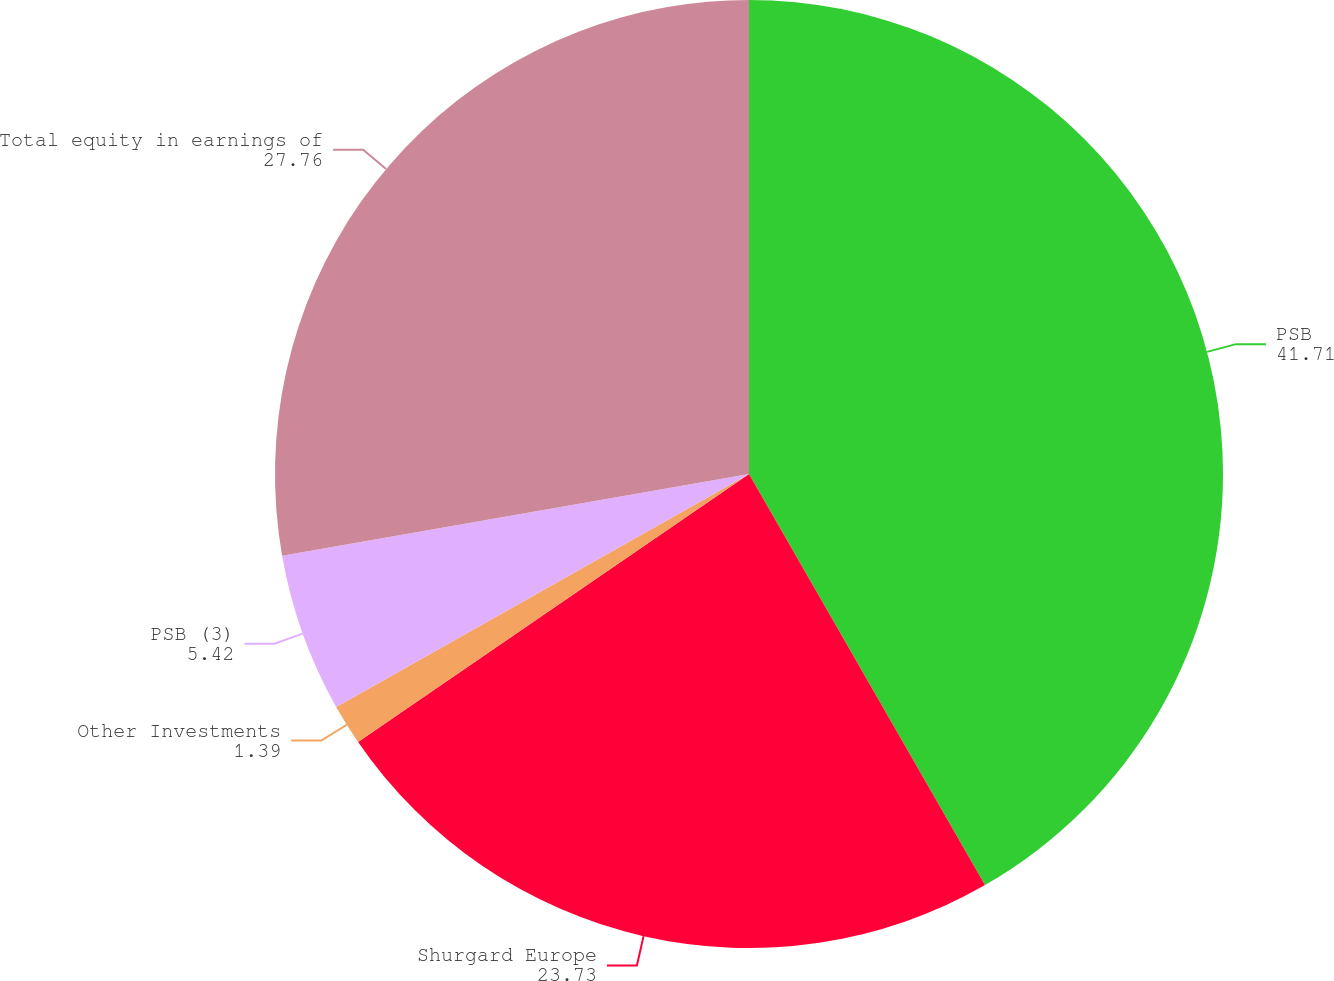<chart> <loc_0><loc_0><loc_500><loc_500><pie_chart><fcel>PSB<fcel>Shurgard Europe<fcel>Other Investments<fcel>PSB (3)<fcel>Total equity in earnings of<nl><fcel>41.71%<fcel>23.73%<fcel>1.39%<fcel>5.42%<fcel>27.76%<nl></chart> 